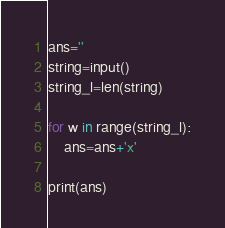Convert code to text. <code><loc_0><loc_0><loc_500><loc_500><_Python_>ans=''
string=input()
string_l=len(string)

for w in range(string_l):
    ans=ans+'x'
    
print(ans)</code> 